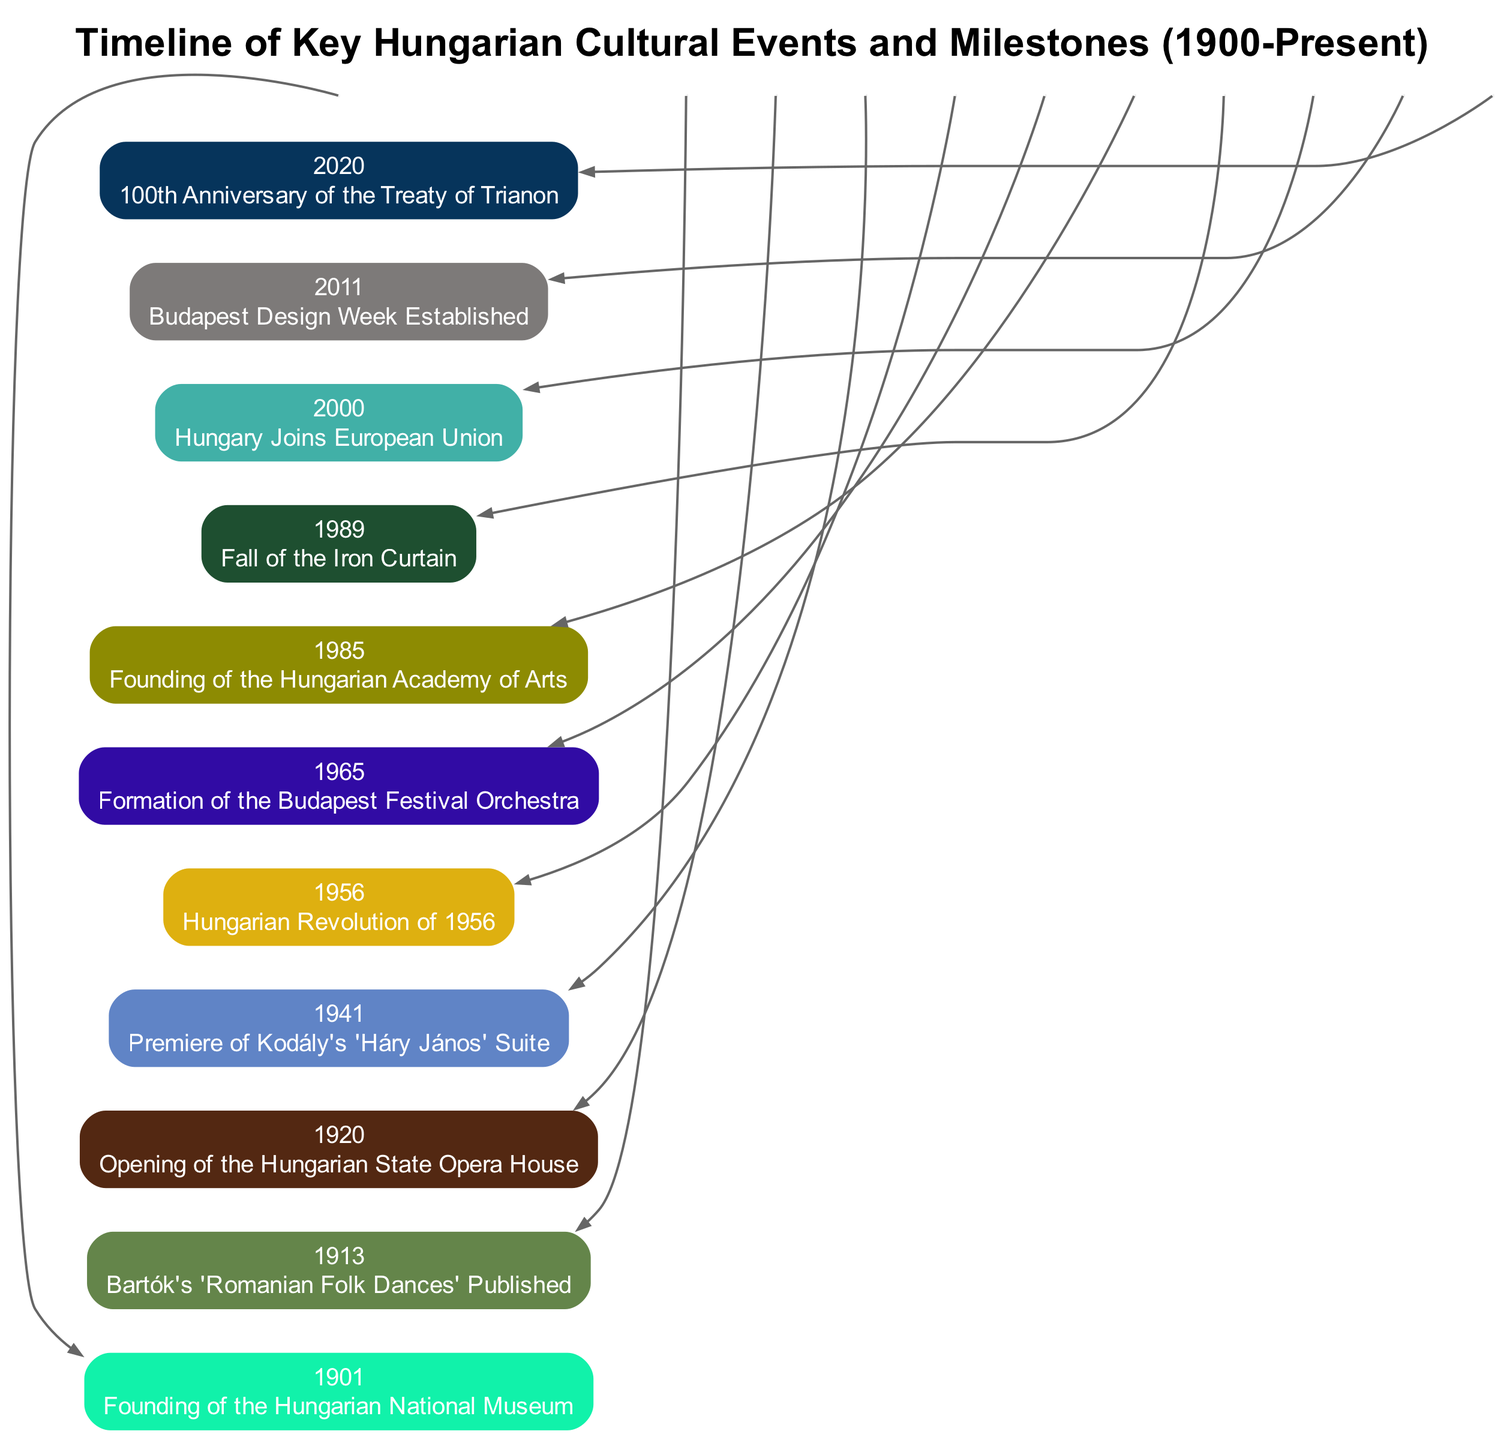What significant event occurred in Hungary in 1901? By looking at the timeline, the first event listed is the founding of the Hungarian National Museum in the year 1901.
Answer: Founding of the Hungarian National Museum What year did Bartók's 'Romanian Folk Dances' get published? The timeline shows that Bartók's 'Romanian Folk Dances' was published in the year 1913.
Answer: 1913 How many key cultural events are listed in the timeline? Counting the events in the timeline shows there are a total of 10 key cultural events listed.
Answer: 10 What is the most recent event highlighted in the timeline? The last event in the timeline indicates that the 100th anniversary of the Treaty of Trianon occurred in 2020.
Answer: 100th Anniversary of the Treaty of Trianon Which event is chronologically between the founding of the Hungarian Academy of Arts and the Fall of the Iron Curtain? According to the timeline, the formation of the Budapest Festival Orchestra in 1965 falls between the founding of the Hungarian Academy of Arts in 1985 and the Fall of the Iron Curtain in 1989.
Answer: Formation of the Budapest Festival Orchestra What major political event in Hungary happened in 1956? The timeline shows that the Hungarian Revolution of 1956 is the major political event listed for that year.
Answer: Hungarian Revolution of 1956 Which event signifies Hungary's entry into the European Union? The timeline specifies that Hungary joined the European Union in the year 2000, signifying a major cultural and political milestone.
Answer: Hungary Joins European Union How are the events visually arranged in the diagram? The events are visually arranged in a linear fashion from left to right, representing the chronological order of the milestones from 1900 to the present.
Answer: Left to right What cultural achievement took place in 1941? According to the timeline, the premiere of Kodály's 'Háry János' Suite occurred in the year 1941.
Answer: Premiere of Kodály's 'Háry János' Suite What event represents a significant cultural response to historical events in Hungary in 1989? The Fall of the Iron Curtain in 1989 signifies a cultural and political response to the historical changes affecting Hungary.
Answer: Fall of the Iron Curtain 